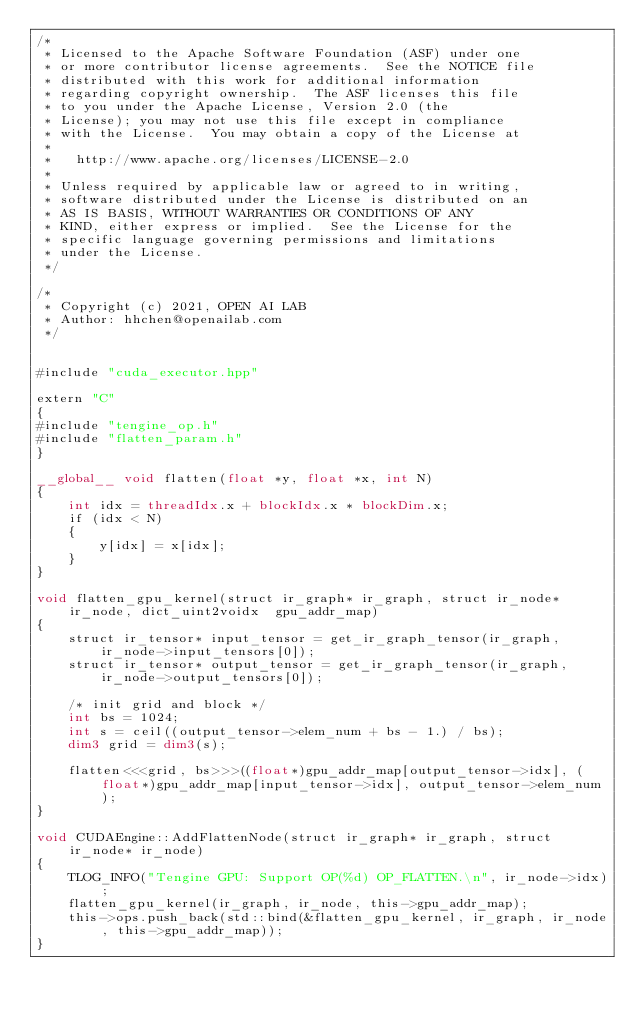<code> <loc_0><loc_0><loc_500><loc_500><_Cuda_>/*
 * Licensed to the Apache Software Foundation (ASF) under one
 * or more contributor license agreements.  See the NOTICE file
 * distributed with this work for additional information
 * regarding copyright ownership.  The ASF licenses this file
 * to you under the Apache License, Version 2.0 (the
 * License); you may not use this file except in compliance
 * with the License.  You may obtain a copy of the License at
 *
 *   http://www.apache.org/licenses/LICENSE-2.0
 *
 * Unless required by applicable law or agreed to in writing,
 * software distributed under the License is distributed on an
 * AS IS BASIS, WITHOUT WARRANTIES OR CONDITIONS OF ANY
 * KIND, either express or implied.  See the License for the
 * specific language governing permissions and limitations
 * under the License.
 */

/*
 * Copyright (c) 2021, OPEN AI LAB
 * Author: hhchen@openailab.com
 */


#include "cuda_executor.hpp"

extern "C"
{
#include "tengine_op.h"
#include "flatten_param.h"
}

__global__ void flatten(float *y, float *x, int N)
{
    int idx = threadIdx.x + blockIdx.x * blockDim.x;
    if (idx < N)
    {
        y[idx] = x[idx];
    }
}

void flatten_gpu_kernel(struct ir_graph* ir_graph, struct ir_node* ir_node, dict_uint2voidx  gpu_addr_map)
{
    struct ir_tensor* input_tensor = get_ir_graph_tensor(ir_graph, ir_node->input_tensors[0]);
    struct ir_tensor* output_tensor = get_ir_graph_tensor(ir_graph, ir_node->output_tensors[0]);

    /* init grid and block */
    int bs = 1024;
    int s = ceil((output_tensor->elem_num + bs - 1.) / bs);
    dim3 grid = dim3(s);

    flatten<<<grid, bs>>>((float*)gpu_addr_map[output_tensor->idx], (float*)gpu_addr_map[input_tensor->idx], output_tensor->elem_num);
}

void CUDAEngine::AddFlattenNode(struct ir_graph* ir_graph, struct ir_node* ir_node)
{
    TLOG_INFO("Tengine GPU: Support OP(%d) OP_FLATTEN.\n", ir_node->idx);
    flatten_gpu_kernel(ir_graph, ir_node, this->gpu_addr_map);
    this->ops.push_back(std::bind(&flatten_gpu_kernel, ir_graph, ir_node, this->gpu_addr_map));
}
</code> 